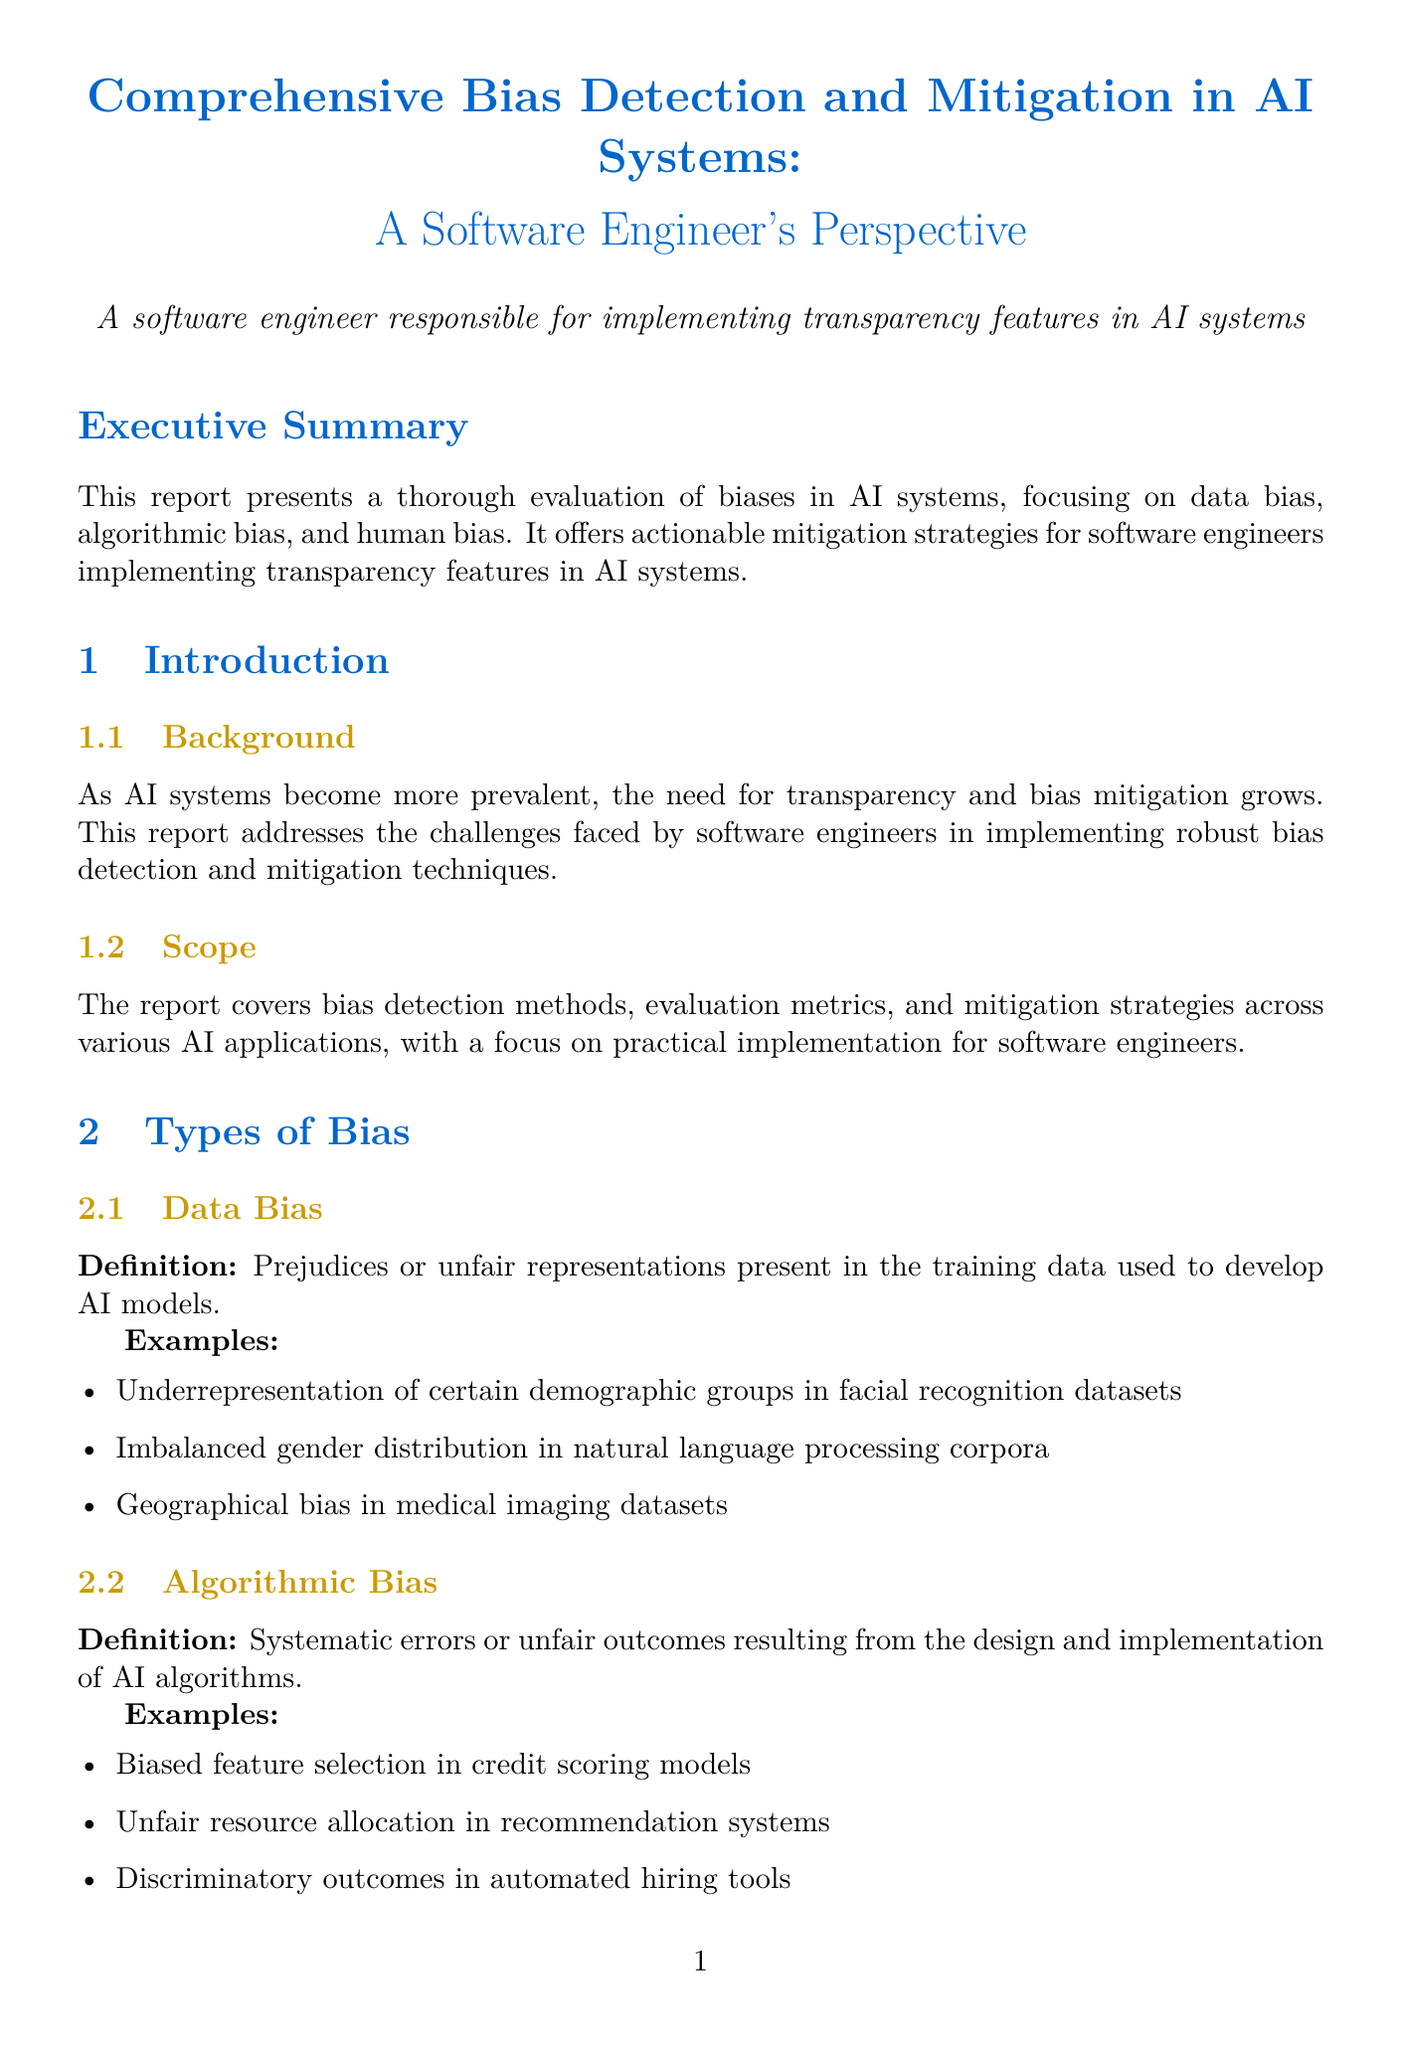What is the title of the report? The title of the report is the main heading at the top of the document, which summarizes the content.
Answer: Comprehensive Bias Detection and Mitigation in AI Systems: A Software Engineer's Perspective What types of bias are identified in the report? The report specifies three main types of bias present in AI systems, categorized in the section on types of bias.
Answer: Data bias, algorithmic bias, human bias What is one example of data bias mentioned? The report provides specific examples under the data bias category to illustrate its meaning.
Answer: Underrepresentation of certain demographic groups in facial recognition datasets What is one bias mitigation strategy related to algorithm design? The report highlights various strategies for reducing bias; one of them involves the design of algorithms.
Answer: Implementing fairness constraints in model optimization What tool is mentioned for bias detection and mitigation? The report lists tools and frameworks that aid in bias detection and mitigation, detailing their purpose and use cases.
Answer: AI Fairness 360 How many case studies are included in the report? The number of case studies is explicitly stated in the section dedicated to them within the document.
Answer: Two What is one lesson learned from the case study on Amazon's AI recruiting tool? The document summarizes lessons derived from case studies, providing insights into bias mitigation.
Answer: Importance of diverse training data and regular bias audits in HR tech What future direction is proposed in the conclusion? The conclusion outlines future directions for bias mitigation, providing a vision for ongoing improvement.
Answer: Integration of bias mitigation techniques into standard software development practices Who are the authors of the reference titled "A Survey on Bias and Fairness in Machine Learning"? This information is presented in the references section, showing who contributed to the listed works.
Answer: Mehrabi, N., Morstatter, F., Saxena, N., Lerman, K., & Galstyan, A 